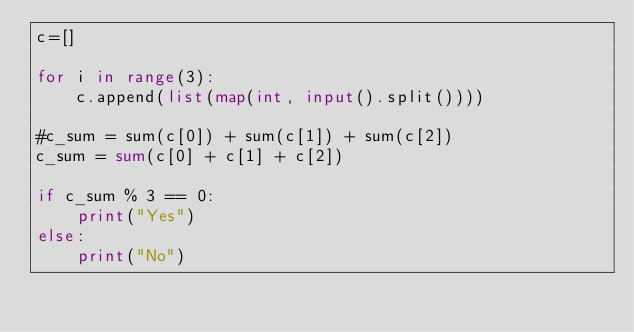Convert code to text. <code><loc_0><loc_0><loc_500><loc_500><_Python_>c=[]

for i in range(3):
    c.append(list(map(int, input().split())))

#c_sum = sum(c[0]) + sum(c[1]) + sum(c[2])
c_sum = sum(c[0] + c[1] + c[2])

if c_sum % 3 == 0:
    print("Yes")
else:
    print("No")</code> 